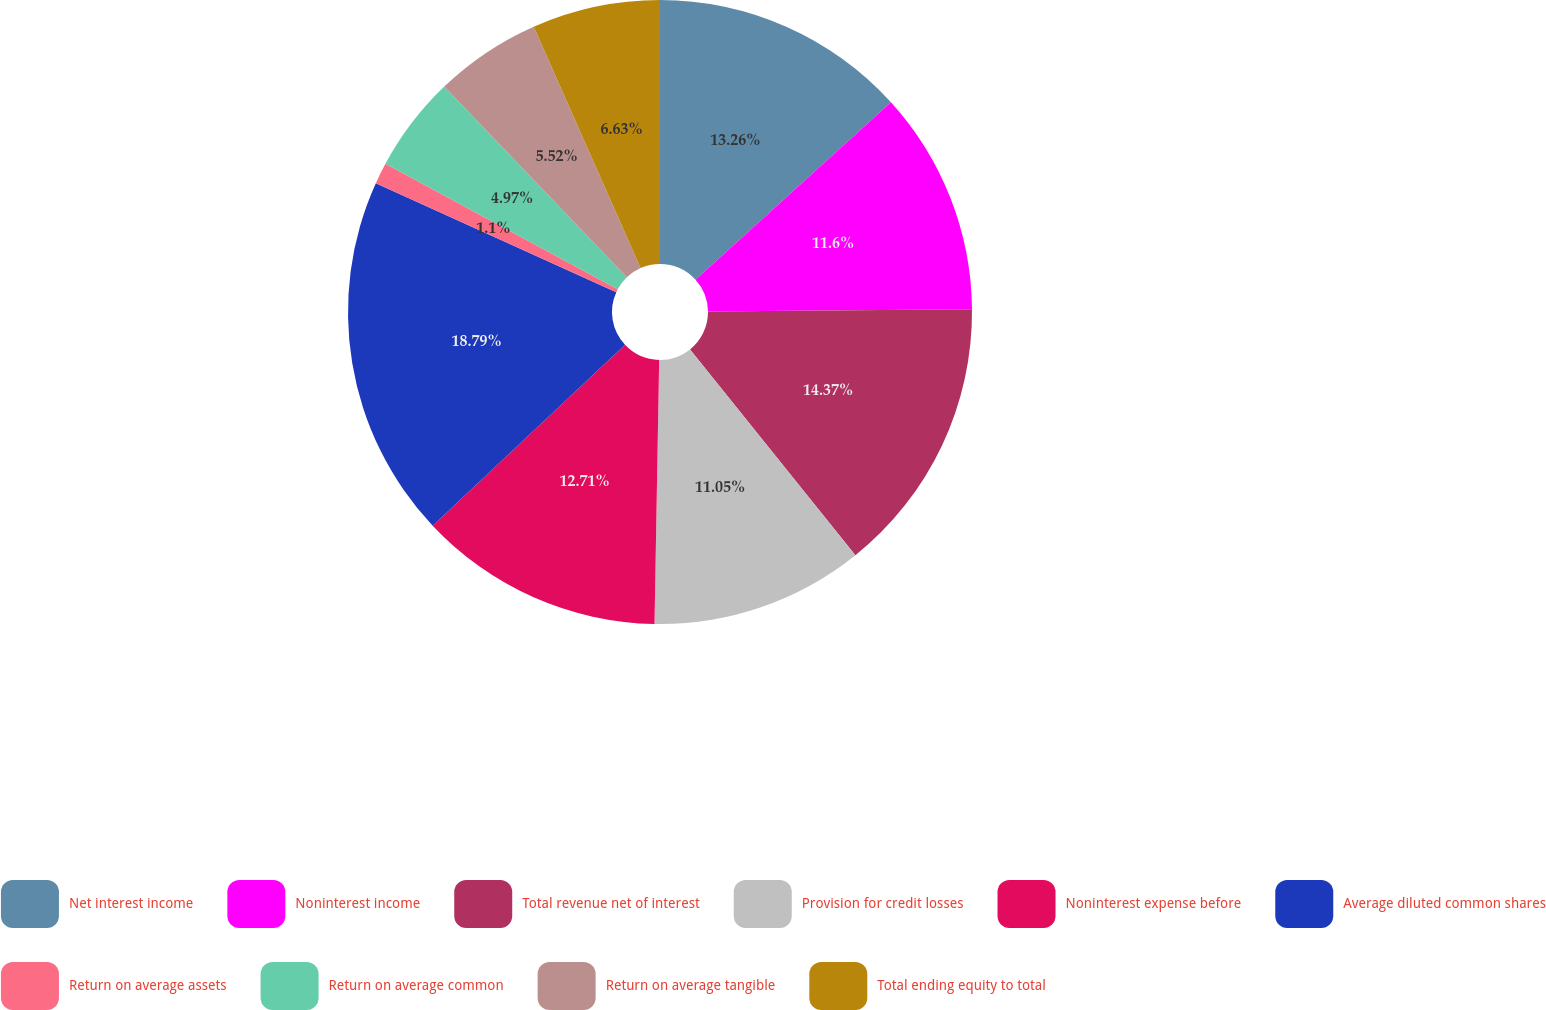Convert chart to OTSL. <chart><loc_0><loc_0><loc_500><loc_500><pie_chart><fcel>Net interest income<fcel>Noninterest income<fcel>Total revenue net of interest<fcel>Provision for credit losses<fcel>Noninterest expense before<fcel>Average diluted common shares<fcel>Return on average assets<fcel>Return on average common<fcel>Return on average tangible<fcel>Total ending equity to total<nl><fcel>13.26%<fcel>11.6%<fcel>14.36%<fcel>11.05%<fcel>12.71%<fcel>18.78%<fcel>1.1%<fcel>4.97%<fcel>5.52%<fcel>6.63%<nl></chart> 